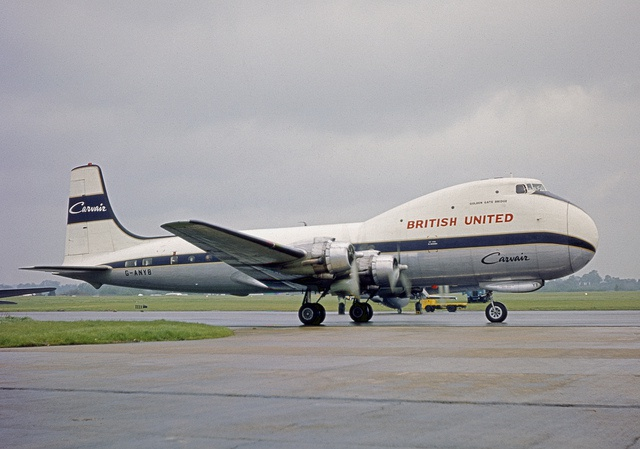Describe the objects in this image and their specific colors. I can see airplane in darkgray, lightgray, black, and gray tones and truck in darkgray, olive, black, and gray tones in this image. 